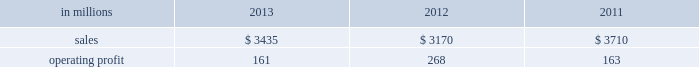Sales volumes in 2013 increased from 2012 , primarily for fluff pulp , reflecting improved market demand and a change in our product mix with a full year of fluff pulp production at our franklin , virginia mill .
Average sales price realizations were lower for fluff pulp while prices for market pulp increased .
Input costs for wood , fuels and chemicals were higher .
Mill operating costs were significantly lower largely due to the absence of costs associated with the start-up of the franklin mill in 2012 .
Planned maintenance downtime costs were higher .
In the first quarter of 2014 , sales volumes are expected to be slightly lower compared with the fourth quarter of 2013 .
Average sales price realizations are expected to improve , reflecting the further realization of previously announced sales price increases for softwood pulp and fluff pulp .
Input costs should be flat .
Planned maintenance downtime costs should be about $ 11 million higher than in the fourth quarter of 2013 .
Operating profits will also be negatively impacted by the severe winter weather in the first quarter of 2014 .
Consumer packaging demand and pricing for consumer packaging products correlate closely with consumer spending and general economic activity .
In addition to prices and volumes , major factors affecting the profitability of consumer packaging are raw material and energy costs , freight costs , manufacturing efficiency and product mix .
Consumer packaging net sales in 2013 increased 8% ( 8 % ) from 2012 , but decreased 7% ( 7 % ) from 2011 .
Operating profits decreased 40% ( 40 % ) from 2012 and 1% ( 1 % ) from 2011 .
Net sales and operating profits include the shorewood business in 2011 .
Excluding costs associated with the permanent shutdown of a paper machine at our augusta , georgia mill and costs associated with the sale of the shorewood business , 2013 operating profits were 22% ( 22 % ) lower than in 2012 , and 43% ( 43 % ) lower than in 2011 .
Benefits from higher sales volumes ( $ 45 million ) were offset by lower average sales price realizations and an unfavorable mix ( $ 50 million ) , higher operating costs including incremental costs resulting from the shutdown of a paper machine at our augusta , georgia mill ( $ 46 million ) and higher input costs ( $ 6 million ) .
In addition , operating profits in 2013 included restructuring costs of $ 45 million related to the permanent shutdown of a paper machine at our augusta , georgia mill and $ 2 million of costs associated with the sale of the shorewood business .
Operating profits in 2012 included a gain of $ 3 million related to the sale of the shorewood business , while operating profits in 2011 included a $ 129 million fixed asset impairment charge for the north american shorewood business and $ 72 million for other charges associated with the sale of the shorewood business .
Consumer packaging .
North american consumer packaging net sales were $ 2.0 billion in 2013 compared with $ 2.0 billion in 2012 and $ 2.5 billion in 2011 .
Operating profits were $ 63 million ( $ 110 million excluding paper machine shutdown costs and costs related to the sale of the shorewood business ) in 2013 compared with $ 165 million ( $ 162 million excluding charges associated with the sale of the shorewood business ) in 2012 and $ 35 million ( $ 236 million excluding asset impairment charges and other costs associated with the sale of the shorewood business ) in 2011 .
Coated paperboard sales volumes in 2013 were higher than in 2012 reflecting stronger market demand .
Average sales price realizations were lower year-over- year despite the realization of price increases in the second half of 2013 .
Input costs for wood and energy increased , but were partially offset by lower costs for chemicals .
Planned maintenance downtime costs were slightly lower .
Market-related downtime was about 24000 tons in 2013 compared with about 113000 tons in 2012 .
The permanent shutdown of a paper machine at our augusta , georgia mill in the first quarter of 2013 reduced capacity by 140000 tons in 2013 compared with 2012 .
Foodservice sales volumes increased slightly in 2013 compared with 2012 despite softer market demand .
Average sales margins were higher reflecting lower input costs for board and resins and a more favorable product mix .
Operating costs and distribution costs were both higher .
The u.s.shorewood business was sold december 31 , 2011 and the non-u.s .
Business was sold in january looking ahead to the first quarter of 2014 , coated paperboard sales volumes are expected to be seasonally weaker than in the fourth quarter of 2013 .
Average sales price realizations are expected to be slightly higher , and margins should also benefit from a more favorable product mix .
Input costs are expected to be higher for energy , chemicals and wood .
Planned maintenance downtime costs should be $ 8 million lower with a planned maintenance outage scheduled at the augusta mill in the first quarter .
The severe winter weather in the first quarter of 2014 will negatively impact operating profits .
Foodservice sales volumes are expected to be seasonally lower .
Average sales margins are expected to improve due to the realization of sales price increases effective with our january contract openers and a more favorable product mix. .
In 2012 what percentage of consumer packaging sales is attributable to north american consumer packaging net sales? 
Computations: ((2 * 1000) / 3170)
Answer: 0.63091. Sales volumes in 2013 increased from 2012 , primarily for fluff pulp , reflecting improved market demand and a change in our product mix with a full year of fluff pulp production at our franklin , virginia mill .
Average sales price realizations were lower for fluff pulp while prices for market pulp increased .
Input costs for wood , fuels and chemicals were higher .
Mill operating costs were significantly lower largely due to the absence of costs associated with the start-up of the franklin mill in 2012 .
Planned maintenance downtime costs were higher .
In the first quarter of 2014 , sales volumes are expected to be slightly lower compared with the fourth quarter of 2013 .
Average sales price realizations are expected to improve , reflecting the further realization of previously announced sales price increases for softwood pulp and fluff pulp .
Input costs should be flat .
Planned maintenance downtime costs should be about $ 11 million higher than in the fourth quarter of 2013 .
Operating profits will also be negatively impacted by the severe winter weather in the first quarter of 2014 .
Consumer packaging demand and pricing for consumer packaging products correlate closely with consumer spending and general economic activity .
In addition to prices and volumes , major factors affecting the profitability of consumer packaging are raw material and energy costs , freight costs , manufacturing efficiency and product mix .
Consumer packaging net sales in 2013 increased 8% ( 8 % ) from 2012 , but decreased 7% ( 7 % ) from 2011 .
Operating profits decreased 40% ( 40 % ) from 2012 and 1% ( 1 % ) from 2011 .
Net sales and operating profits include the shorewood business in 2011 .
Excluding costs associated with the permanent shutdown of a paper machine at our augusta , georgia mill and costs associated with the sale of the shorewood business , 2013 operating profits were 22% ( 22 % ) lower than in 2012 , and 43% ( 43 % ) lower than in 2011 .
Benefits from higher sales volumes ( $ 45 million ) were offset by lower average sales price realizations and an unfavorable mix ( $ 50 million ) , higher operating costs including incremental costs resulting from the shutdown of a paper machine at our augusta , georgia mill ( $ 46 million ) and higher input costs ( $ 6 million ) .
In addition , operating profits in 2013 included restructuring costs of $ 45 million related to the permanent shutdown of a paper machine at our augusta , georgia mill and $ 2 million of costs associated with the sale of the shorewood business .
Operating profits in 2012 included a gain of $ 3 million related to the sale of the shorewood business , while operating profits in 2011 included a $ 129 million fixed asset impairment charge for the north american shorewood business and $ 72 million for other charges associated with the sale of the shorewood business .
Consumer packaging .
North american consumer packaging net sales were $ 2.0 billion in 2013 compared with $ 2.0 billion in 2012 and $ 2.5 billion in 2011 .
Operating profits were $ 63 million ( $ 110 million excluding paper machine shutdown costs and costs related to the sale of the shorewood business ) in 2013 compared with $ 165 million ( $ 162 million excluding charges associated with the sale of the shorewood business ) in 2012 and $ 35 million ( $ 236 million excluding asset impairment charges and other costs associated with the sale of the shorewood business ) in 2011 .
Coated paperboard sales volumes in 2013 were higher than in 2012 reflecting stronger market demand .
Average sales price realizations were lower year-over- year despite the realization of price increases in the second half of 2013 .
Input costs for wood and energy increased , but were partially offset by lower costs for chemicals .
Planned maintenance downtime costs were slightly lower .
Market-related downtime was about 24000 tons in 2013 compared with about 113000 tons in 2012 .
The permanent shutdown of a paper machine at our augusta , georgia mill in the first quarter of 2013 reduced capacity by 140000 tons in 2013 compared with 2012 .
Foodservice sales volumes increased slightly in 2013 compared with 2012 despite softer market demand .
Average sales margins were higher reflecting lower input costs for board and resins and a more favorable product mix .
Operating costs and distribution costs were both higher .
The u.s.shorewood business was sold december 31 , 2011 and the non-u.s .
Business was sold in january looking ahead to the first quarter of 2014 , coated paperboard sales volumes are expected to be seasonally weaker than in the fourth quarter of 2013 .
Average sales price realizations are expected to be slightly higher , and margins should also benefit from a more favorable product mix .
Input costs are expected to be higher for energy , chemicals and wood .
Planned maintenance downtime costs should be $ 8 million lower with a planned maintenance outage scheduled at the augusta mill in the first quarter .
The severe winter weather in the first quarter of 2014 will negatively impact operating profits .
Foodservice sales volumes are expected to be seasonally lower .
Average sales margins are expected to improve due to the realization of sales price increases effective with our january contract openers and a more favorable product mix. .
In 2013 what percentage of consumer packaging sales is attributable to north american consumer packaging net sales? 
Computations: ((2 * 1000) / 3435)
Answer: 0.58224. Sales volumes in 2013 increased from 2012 , primarily for fluff pulp , reflecting improved market demand and a change in our product mix with a full year of fluff pulp production at our franklin , virginia mill .
Average sales price realizations were lower for fluff pulp while prices for market pulp increased .
Input costs for wood , fuels and chemicals were higher .
Mill operating costs were significantly lower largely due to the absence of costs associated with the start-up of the franklin mill in 2012 .
Planned maintenance downtime costs were higher .
In the first quarter of 2014 , sales volumes are expected to be slightly lower compared with the fourth quarter of 2013 .
Average sales price realizations are expected to improve , reflecting the further realization of previously announced sales price increases for softwood pulp and fluff pulp .
Input costs should be flat .
Planned maintenance downtime costs should be about $ 11 million higher than in the fourth quarter of 2013 .
Operating profits will also be negatively impacted by the severe winter weather in the first quarter of 2014 .
Consumer packaging demand and pricing for consumer packaging products correlate closely with consumer spending and general economic activity .
In addition to prices and volumes , major factors affecting the profitability of consumer packaging are raw material and energy costs , freight costs , manufacturing efficiency and product mix .
Consumer packaging net sales in 2013 increased 8% ( 8 % ) from 2012 , but decreased 7% ( 7 % ) from 2011 .
Operating profits decreased 40% ( 40 % ) from 2012 and 1% ( 1 % ) from 2011 .
Net sales and operating profits include the shorewood business in 2011 .
Excluding costs associated with the permanent shutdown of a paper machine at our augusta , georgia mill and costs associated with the sale of the shorewood business , 2013 operating profits were 22% ( 22 % ) lower than in 2012 , and 43% ( 43 % ) lower than in 2011 .
Benefits from higher sales volumes ( $ 45 million ) were offset by lower average sales price realizations and an unfavorable mix ( $ 50 million ) , higher operating costs including incremental costs resulting from the shutdown of a paper machine at our augusta , georgia mill ( $ 46 million ) and higher input costs ( $ 6 million ) .
In addition , operating profits in 2013 included restructuring costs of $ 45 million related to the permanent shutdown of a paper machine at our augusta , georgia mill and $ 2 million of costs associated with the sale of the shorewood business .
Operating profits in 2012 included a gain of $ 3 million related to the sale of the shorewood business , while operating profits in 2011 included a $ 129 million fixed asset impairment charge for the north american shorewood business and $ 72 million for other charges associated with the sale of the shorewood business .
Consumer packaging .
North american consumer packaging net sales were $ 2.0 billion in 2013 compared with $ 2.0 billion in 2012 and $ 2.5 billion in 2011 .
Operating profits were $ 63 million ( $ 110 million excluding paper machine shutdown costs and costs related to the sale of the shorewood business ) in 2013 compared with $ 165 million ( $ 162 million excluding charges associated with the sale of the shorewood business ) in 2012 and $ 35 million ( $ 236 million excluding asset impairment charges and other costs associated with the sale of the shorewood business ) in 2011 .
Coated paperboard sales volumes in 2013 were higher than in 2012 reflecting stronger market demand .
Average sales price realizations were lower year-over- year despite the realization of price increases in the second half of 2013 .
Input costs for wood and energy increased , but were partially offset by lower costs for chemicals .
Planned maintenance downtime costs were slightly lower .
Market-related downtime was about 24000 tons in 2013 compared with about 113000 tons in 2012 .
The permanent shutdown of a paper machine at our augusta , georgia mill in the first quarter of 2013 reduced capacity by 140000 tons in 2013 compared with 2012 .
Foodservice sales volumes increased slightly in 2013 compared with 2012 despite softer market demand .
Average sales margins were higher reflecting lower input costs for board and resins and a more favorable product mix .
Operating costs and distribution costs were both higher .
The u.s.shorewood business was sold december 31 , 2011 and the non-u.s .
Business was sold in january looking ahead to the first quarter of 2014 , coated paperboard sales volumes are expected to be seasonally weaker than in the fourth quarter of 2013 .
Average sales price realizations are expected to be slightly higher , and margins should also benefit from a more favorable product mix .
Input costs are expected to be higher for energy , chemicals and wood .
Planned maintenance downtime costs should be $ 8 million lower with a planned maintenance outage scheduled at the augusta mill in the first quarter .
The severe winter weather in the first quarter of 2014 will negatively impact operating profits .
Foodservice sales volumes are expected to be seasonally lower .
Average sales margins are expected to improve due to the realization of sales price increases effective with our january contract openers and a more favorable product mix. .
What was the average consumer packaging net sales for north america from 2011 to 2013? 
Computations: ((((2.0 + 2.0) + 2.5) + 3) / 2)
Answer: 4.75. 